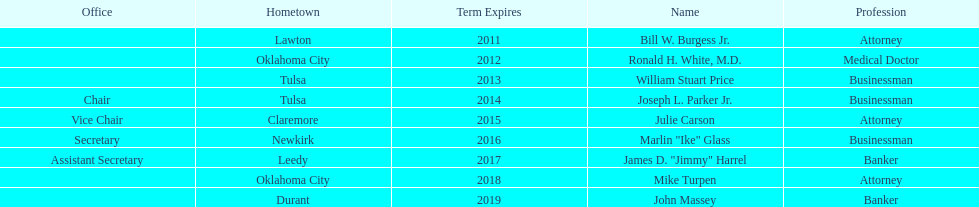What is the total number of state regents who are attorneys? 3. 